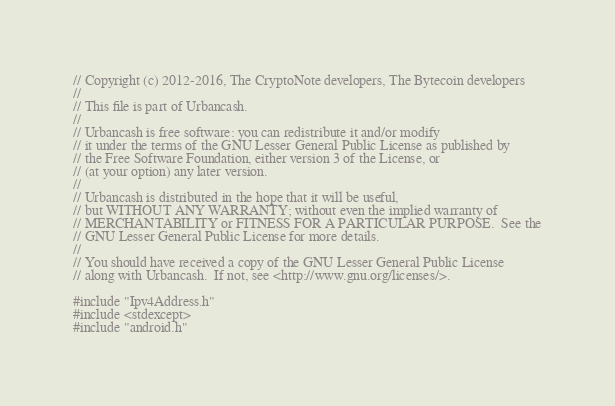Convert code to text. <code><loc_0><loc_0><loc_500><loc_500><_C++_>// Copyright (c) 2012-2016, The CryptoNote developers, The Bytecoin developers
//
// This file is part of Urbancash.
//
// Urbancash is free software: you can redistribute it and/or modify
// it under the terms of the GNU Lesser General Public License as published by
// the Free Software Foundation, either version 3 of the License, or
// (at your option) any later version.
//
// Urbancash is distributed in the hope that it will be useful,
// but WITHOUT ANY WARRANTY; without even the implied warranty of
// MERCHANTABILITY or FITNESS FOR A PARTICULAR PURPOSE.  See the
// GNU Lesser General Public License for more details.
//
// You should have received a copy of the GNU Lesser General Public License
// along with Urbancash.  If not, see <http://www.gnu.org/licenses/>.

#include "Ipv4Address.h"
#include <stdexcept>
#include "android.h"
</code> 